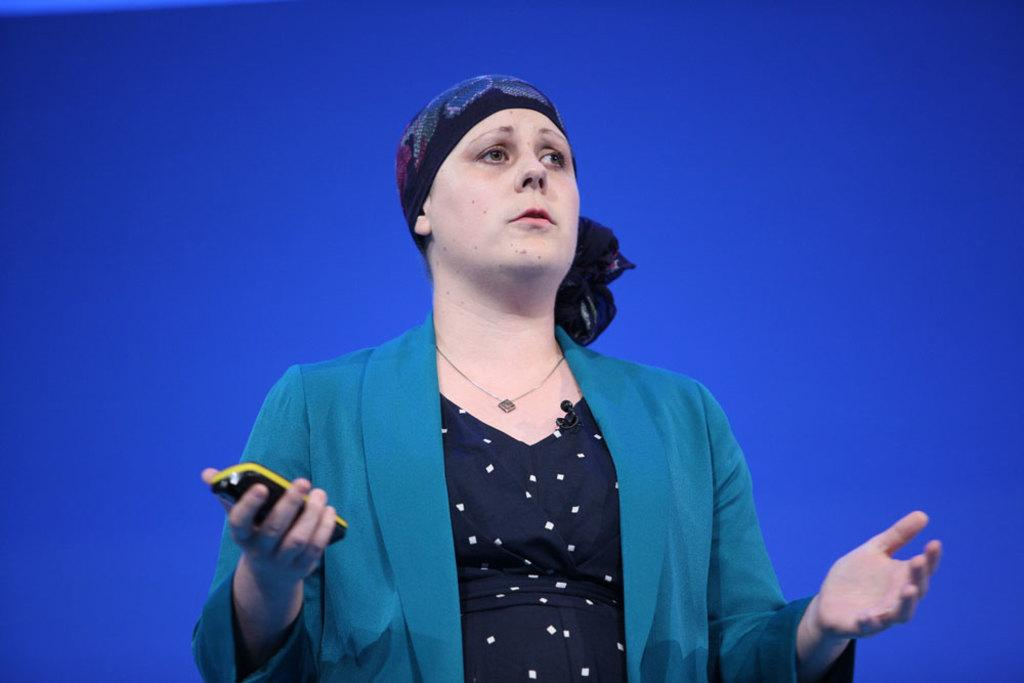Who is the main subject in the image? There is a woman in the image. What is the woman doing with her hands? The woman is spreading her hands. What object can be seen in the woman's hand on the left side? There is a mobile phone in the woman's hand on the left side. What type of property is visible in the background of the image? There is no property visible in the background of the image. What is the woman standing on in the image? The woman's feet are not visible in the image, so it cannot be determined what she is standing on. 